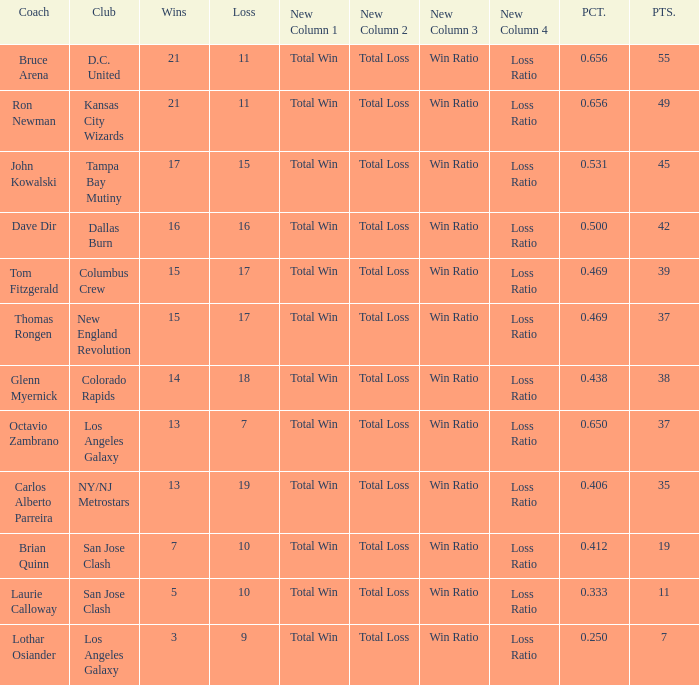What is the sum of points when Bruce Arena has 21 wins? 55.0. 